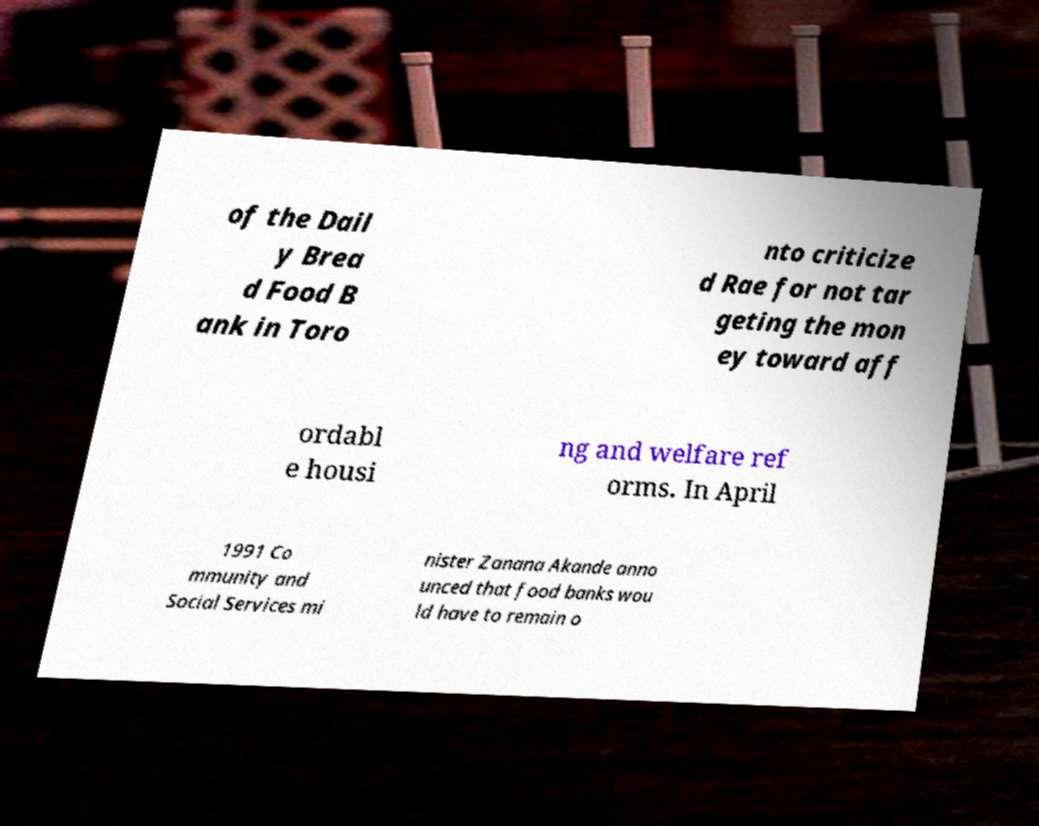Can you accurately transcribe the text from the provided image for me? of the Dail y Brea d Food B ank in Toro nto criticize d Rae for not tar geting the mon ey toward aff ordabl e housi ng and welfare ref orms. In April 1991 Co mmunity and Social Services mi nister Zanana Akande anno unced that food banks wou ld have to remain o 